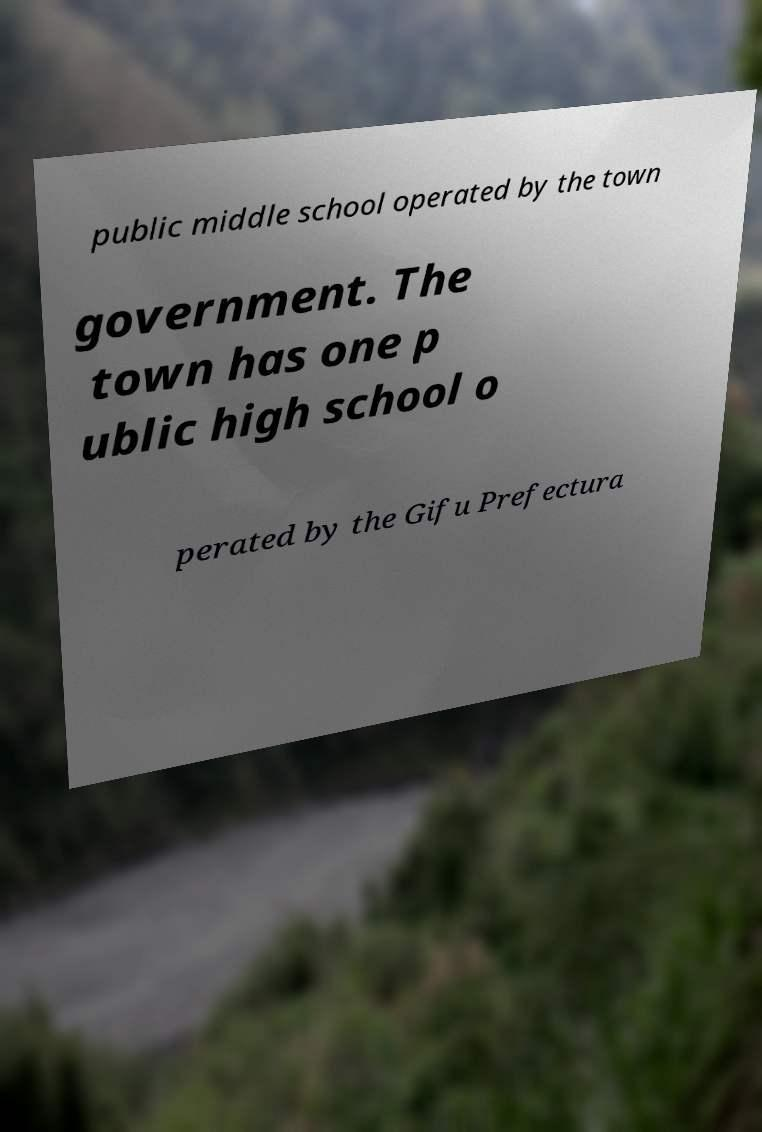Can you read and provide the text displayed in the image?This photo seems to have some interesting text. Can you extract and type it out for me? public middle school operated by the town government. The town has one p ublic high school o perated by the Gifu Prefectura 